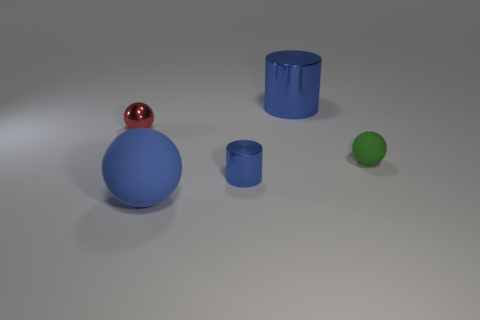Subtract all large blue balls. How many balls are left? 2 Add 4 tiny red cubes. How many objects exist? 9 Subtract all red balls. How many balls are left? 2 Subtract 2 cylinders. How many cylinders are left? 0 Subtract all cyan blocks. How many green spheres are left? 1 Add 4 tiny blue metal cylinders. How many tiny blue metal cylinders are left? 5 Add 1 tiny brown shiny objects. How many tiny brown shiny objects exist? 1 Subtract 0 blue cubes. How many objects are left? 5 Subtract all cylinders. How many objects are left? 3 Subtract all red cylinders. Subtract all blue cubes. How many cylinders are left? 2 